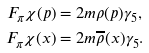Convert formula to latex. <formula><loc_0><loc_0><loc_500><loc_500>F _ { \pi } \chi ( p ) & = 2 m \rho ( p ) \gamma _ { 5 } , \\ F _ { \pi } \chi ( x ) & = 2 m \overline { \rho } ( x ) \gamma _ { 5 } .</formula> 